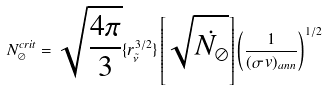Convert formula to latex. <formula><loc_0><loc_0><loc_500><loc_500>N _ { \oslash } ^ { c r i t } = \sqrt { \frac { 4 \pi } { 3 } } \{ r _ { \tilde { \nu } } ^ { 3 / 2 } \} \left [ \sqrt { \dot { N _ { \oslash } } } \right ] \left ( \frac { 1 } { ( \sigma \, v ) _ { a n n } } \right ) ^ { 1 / 2 }</formula> 